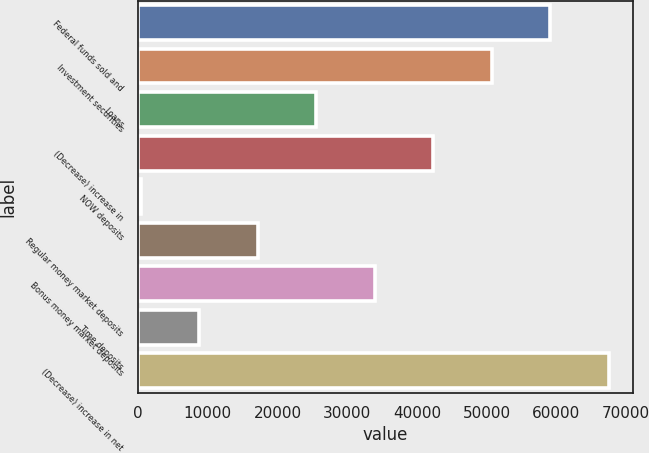Convert chart. <chart><loc_0><loc_0><loc_500><loc_500><bar_chart><fcel>Federal funds sold and<fcel>Investment securities<fcel>Loans<fcel>(Decrease) increase in<fcel>NOW deposits<fcel>Regular money market deposits<fcel>Bonus money market deposits<fcel>Time deposits<fcel>(Decrease) increase in net<nl><fcel>59172.2<fcel>50774.6<fcel>25581.8<fcel>42377<fcel>389<fcel>17184.2<fcel>33979.4<fcel>8786.6<fcel>67569.8<nl></chart> 